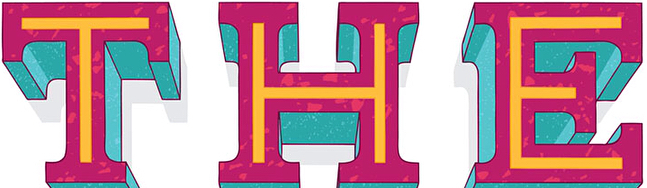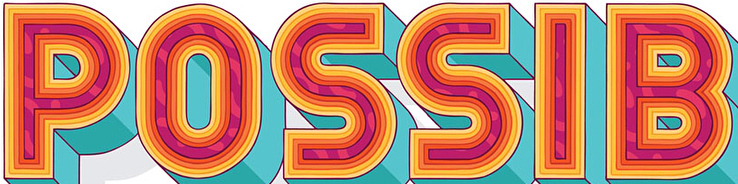What text is displayed in these images sequentially, separated by a semicolon? THE; POSSIB 